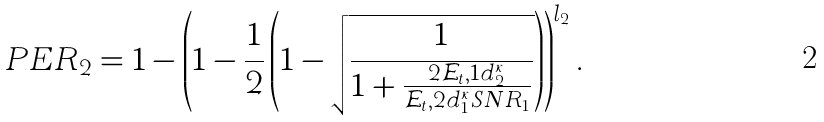<formula> <loc_0><loc_0><loc_500><loc_500>P E R _ { 2 } = 1 - \left ( 1 - \frac { 1 } { 2 } \left ( 1 - \sqrt { \frac { 1 } { 1 + \frac { 2 \mathcal { E } _ { t } , 1 d _ { 2 } ^ { \kappa } } { \mathcal { E } _ { t } , 2 d _ { 1 } ^ { \kappa } S N R _ { 1 } } } } \right ) \right ) ^ { l _ { 2 } } .</formula> 